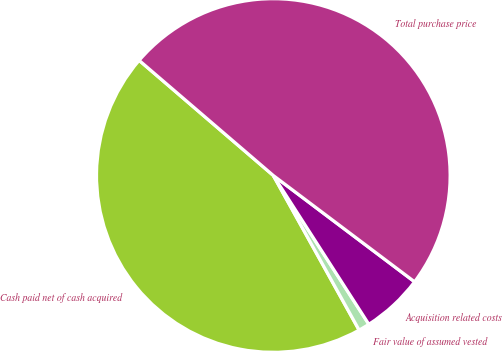<chart> <loc_0><loc_0><loc_500><loc_500><pie_chart><fcel>Cash paid net of cash acquired<fcel>Fair value of assumed vested<fcel>Acquisition related costs<fcel>Total purchase price<nl><fcel>44.35%<fcel>1.02%<fcel>5.65%<fcel>48.98%<nl></chart> 